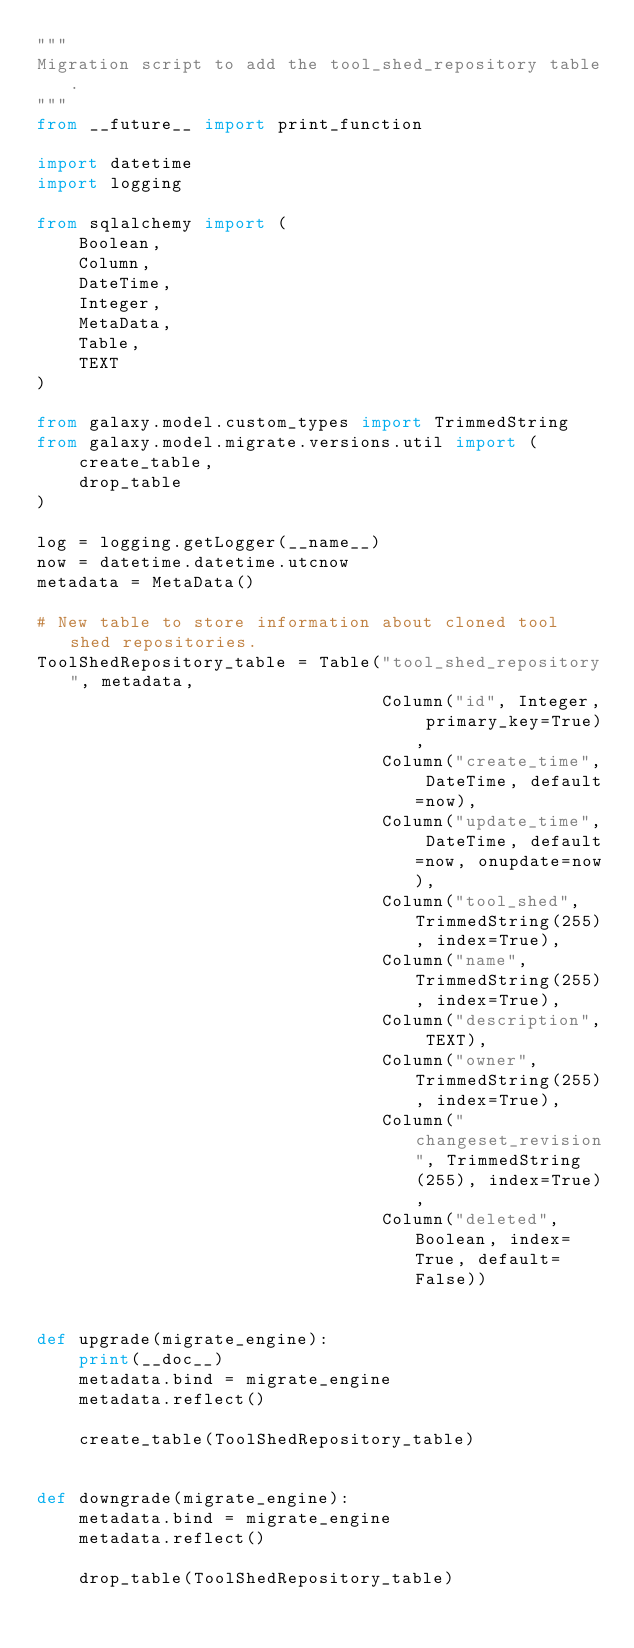<code> <loc_0><loc_0><loc_500><loc_500><_Python_>"""
Migration script to add the tool_shed_repository table.
"""
from __future__ import print_function

import datetime
import logging

from sqlalchemy import (
    Boolean,
    Column,
    DateTime,
    Integer,
    MetaData,
    Table,
    TEXT
)

from galaxy.model.custom_types import TrimmedString
from galaxy.model.migrate.versions.util import (
    create_table,
    drop_table
)

log = logging.getLogger(__name__)
now = datetime.datetime.utcnow
metadata = MetaData()

# New table to store information about cloned tool shed repositories.
ToolShedRepository_table = Table("tool_shed_repository", metadata,
                                 Column("id", Integer, primary_key=True),
                                 Column("create_time", DateTime, default=now),
                                 Column("update_time", DateTime, default=now, onupdate=now),
                                 Column("tool_shed", TrimmedString(255), index=True),
                                 Column("name", TrimmedString(255), index=True),
                                 Column("description", TEXT),
                                 Column("owner", TrimmedString(255), index=True),
                                 Column("changeset_revision", TrimmedString(255), index=True),
                                 Column("deleted", Boolean, index=True, default=False))


def upgrade(migrate_engine):
    print(__doc__)
    metadata.bind = migrate_engine
    metadata.reflect()

    create_table(ToolShedRepository_table)


def downgrade(migrate_engine):
    metadata.bind = migrate_engine
    metadata.reflect()

    drop_table(ToolShedRepository_table)
</code> 